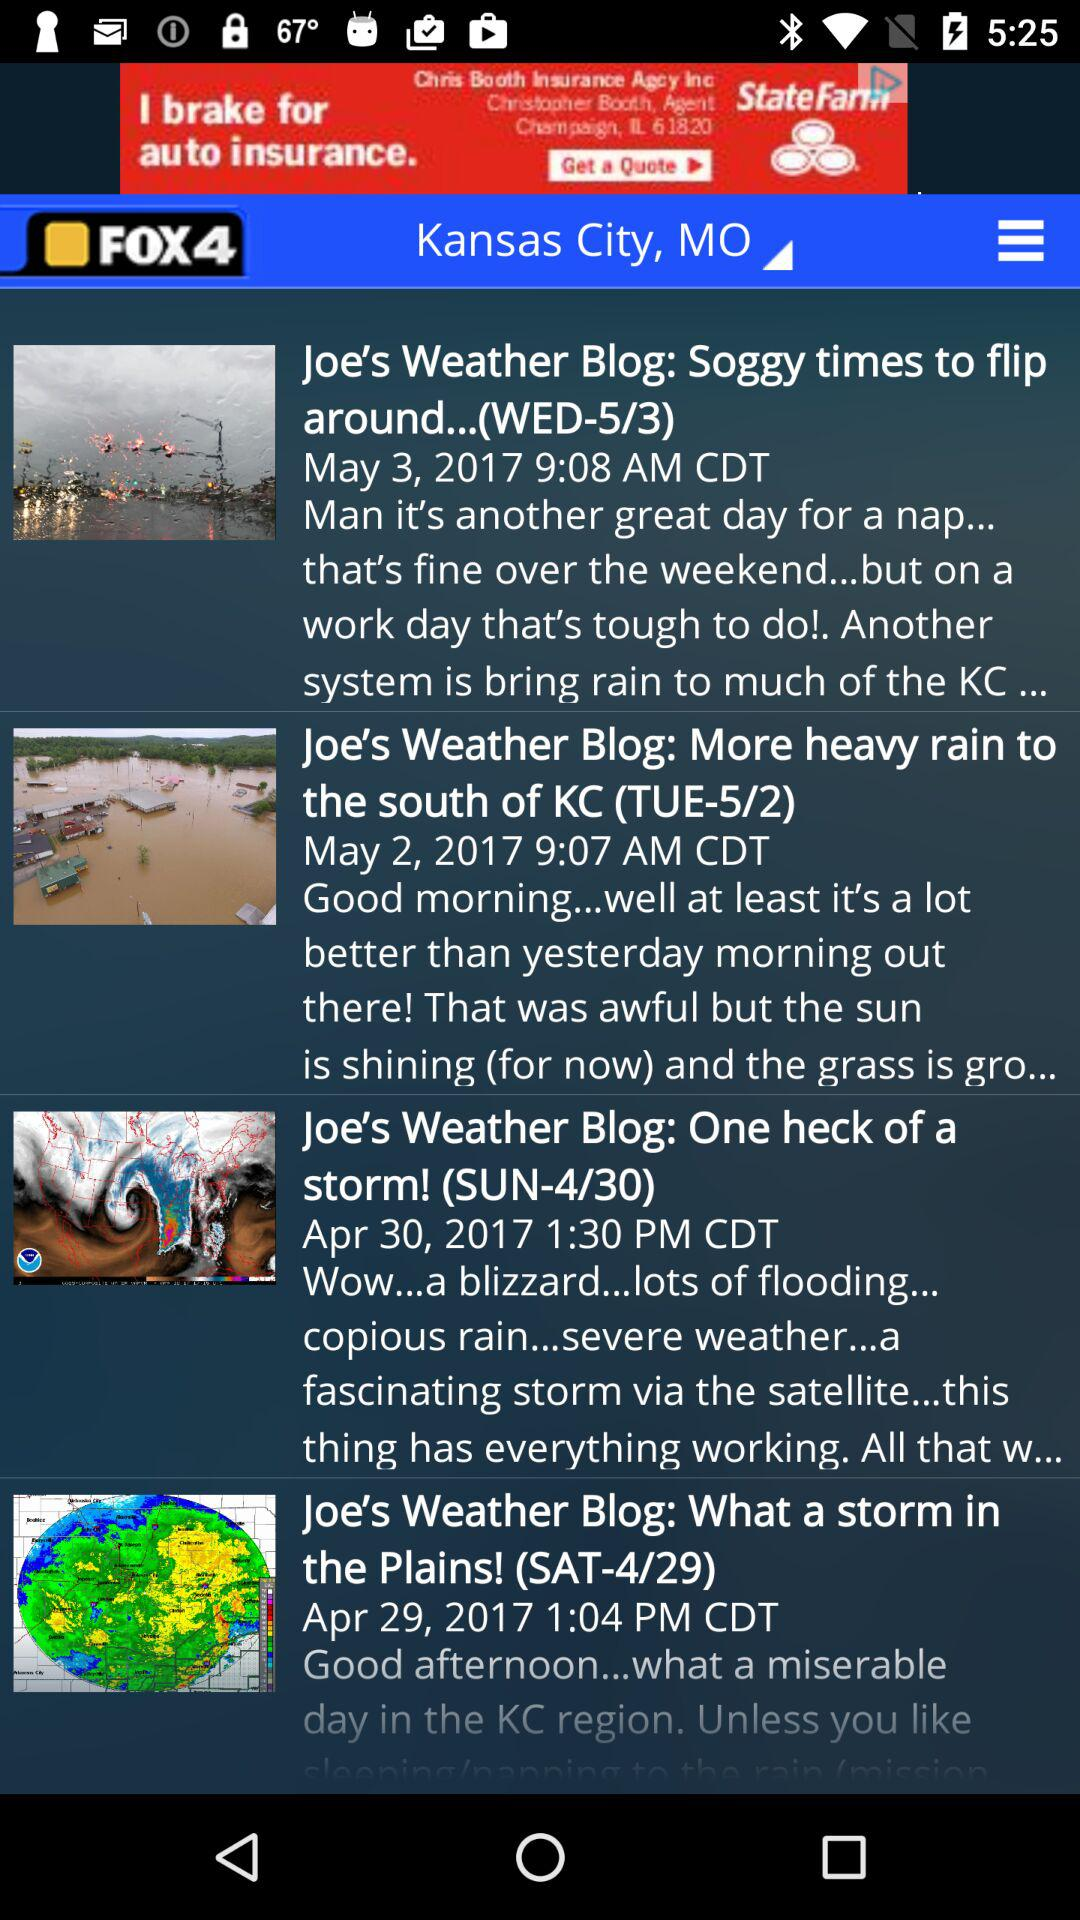How many days are there between the first and last blog posts?
Answer the question using a single word or phrase. 4 